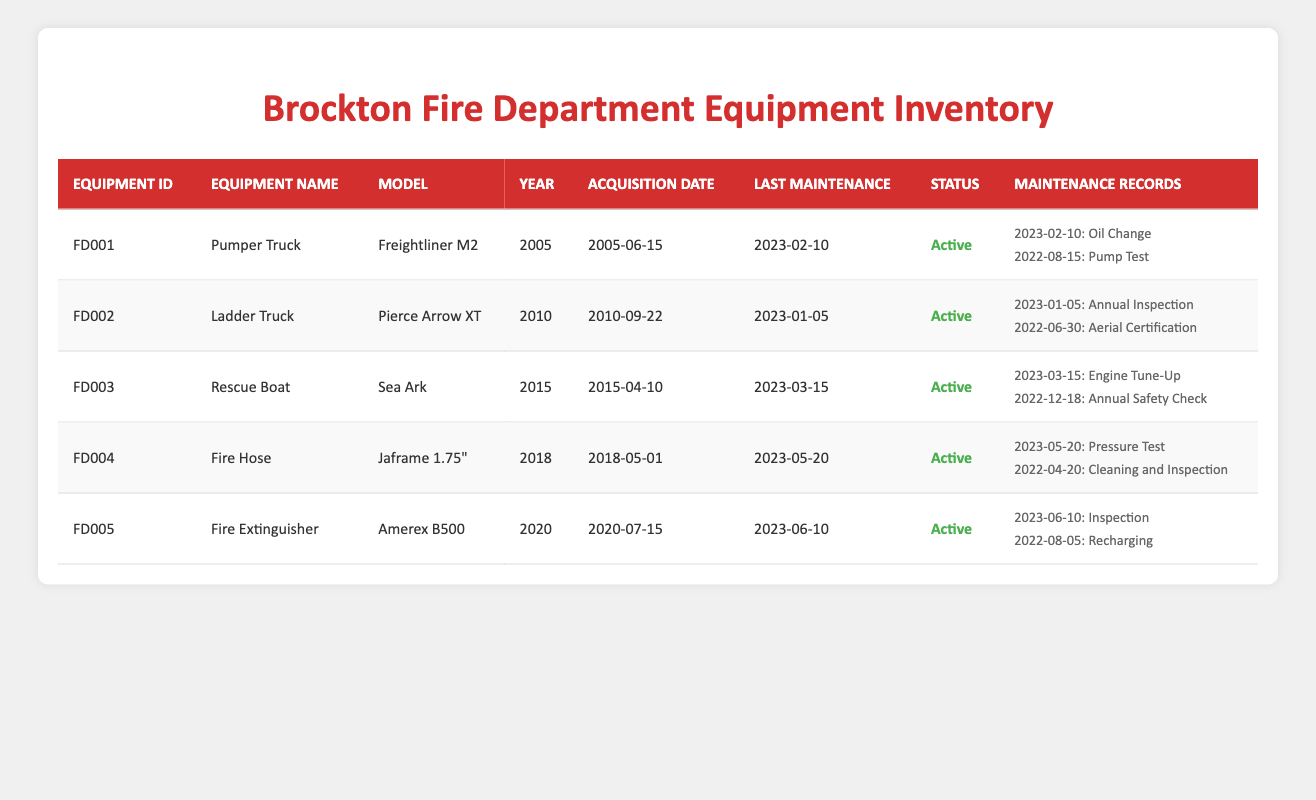What is the model of the Pumper Truck? The Pumper Truck's model is listed in the table next to its equipment name under the "Model" column. It is "Freightliner M2."
Answer: Freightliner M2 When was the Fire Hose acquired? The acquisition date for the Fire Hose is listed in the table under the "Acquisition Date" column. It shows the date as "2018-05-01."
Answer: 2018-05-01 What service type was performed on the Rescue Boat on March 15, 2023? The last maintenance date for the Rescue Boat is noted as "2023-03-15," with the service type also mentioned. On this date, an "Engine Tune-Up" was performed.
Answer: Engine Tune-Up How many maintenance records are there for the Ladder Truck? The Ladder Truck shows two maintenance records in the "Maintenance Records" column. This can be confirmed by counting the entries listed under that equipment, which are the "Annual Inspection" and "Aerial Certification."
Answer: 2 Did the Fire Extinguisher pass inspection on June 10, 2023? The maintenance record for June 10, 2023, indicates that the Fire Extinguisher was fully charged and in compliance, meaning it passed the inspection.
Answer: Yes What is the average year of manufacture for all the equipment listed? The years of manufacture are 2005, 2010, 2015, 2018, and 2020. To find the average, sum them (2005 + 2010 + 2015 + 2018 + 2020 = 10068) and then divide by 5 (10068 / 5 = 2013.6). The average year can be rounded to 2014.
Answer: 2014 Which equipment has the latest last maintenance date? The last maintenance dates for the equipment are 2023-02-10, 2023-01-05, 2023-03-15, 2023-05-20, and 2023-06-10. Comparing these dates, 2023-06-10 is the latest date, which belongs to the Fire Extinguisher.
Answer: Fire Extinguisher What was the status of the Fire Hose as of the last maintenance date? The Fire Hose's status is clearly marked under the "Status" column, indicating it is "Active." This is the status at the time of its last maintenance on 2023-05-20.
Answer: Active Are all pieces of equipment listed as active? All entries in the "Status" column indicate "Active," including the Pumper Truck, Ladder Truck, Rescue Boat, Fire Hose, and Fire Extinguisher. This means that none are non-active.
Answer: Yes 